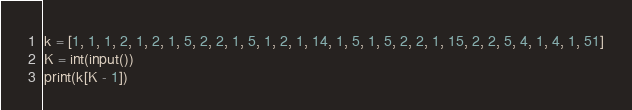Convert code to text. <code><loc_0><loc_0><loc_500><loc_500><_Python_>k = [1, 1, 1, 2, 1, 2, 1, 5, 2, 2, 1, 5, 1, 2, 1, 14, 1, 5, 1, 5, 2, 2, 1, 15, 2, 2, 5, 4, 1, 4, 1, 51]
K = int(input())
print(k[K - 1])</code> 